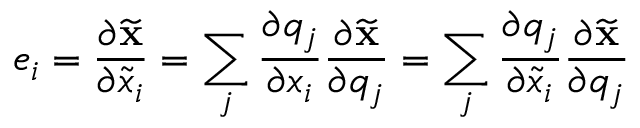Convert formula to latex. <formula><loc_0><loc_0><loc_500><loc_500>e _ { i } = \frac { \partial { { \widetilde { x } } } } { \partial \widetilde { x } _ { i } } = \sum _ { j } \frac { \partial q _ { j } } { \partial x _ { i } } \frac { \partial { { \widetilde { x } } } } { \partial q _ { j } } = \sum _ { j } \frac { \partial q _ { j } } { \partial \widetilde { x } _ { i } } \frac { \partial { { \widetilde { x } } } } { \partial q _ { j } }</formula> 